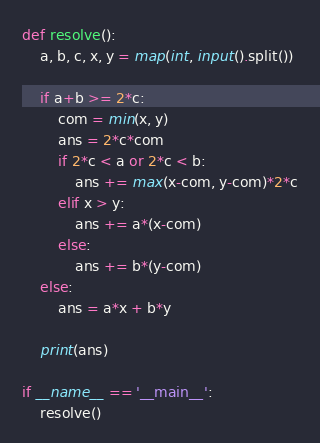<code> <loc_0><loc_0><loc_500><loc_500><_Python_>def resolve():
    a, b, c, x, y = map(int, input().split())

    if a+b >= 2*c:
        com = min(x, y)
        ans = 2*c*com
        if 2*c < a or 2*c < b:
            ans += max(x-com, y-com)*2*c
        elif x > y:
            ans += a*(x-com)
        else:
            ans += b*(y-com)
    else:
        ans = a*x + b*y

    print(ans)

if __name__ == '__main__':
    resolve()</code> 